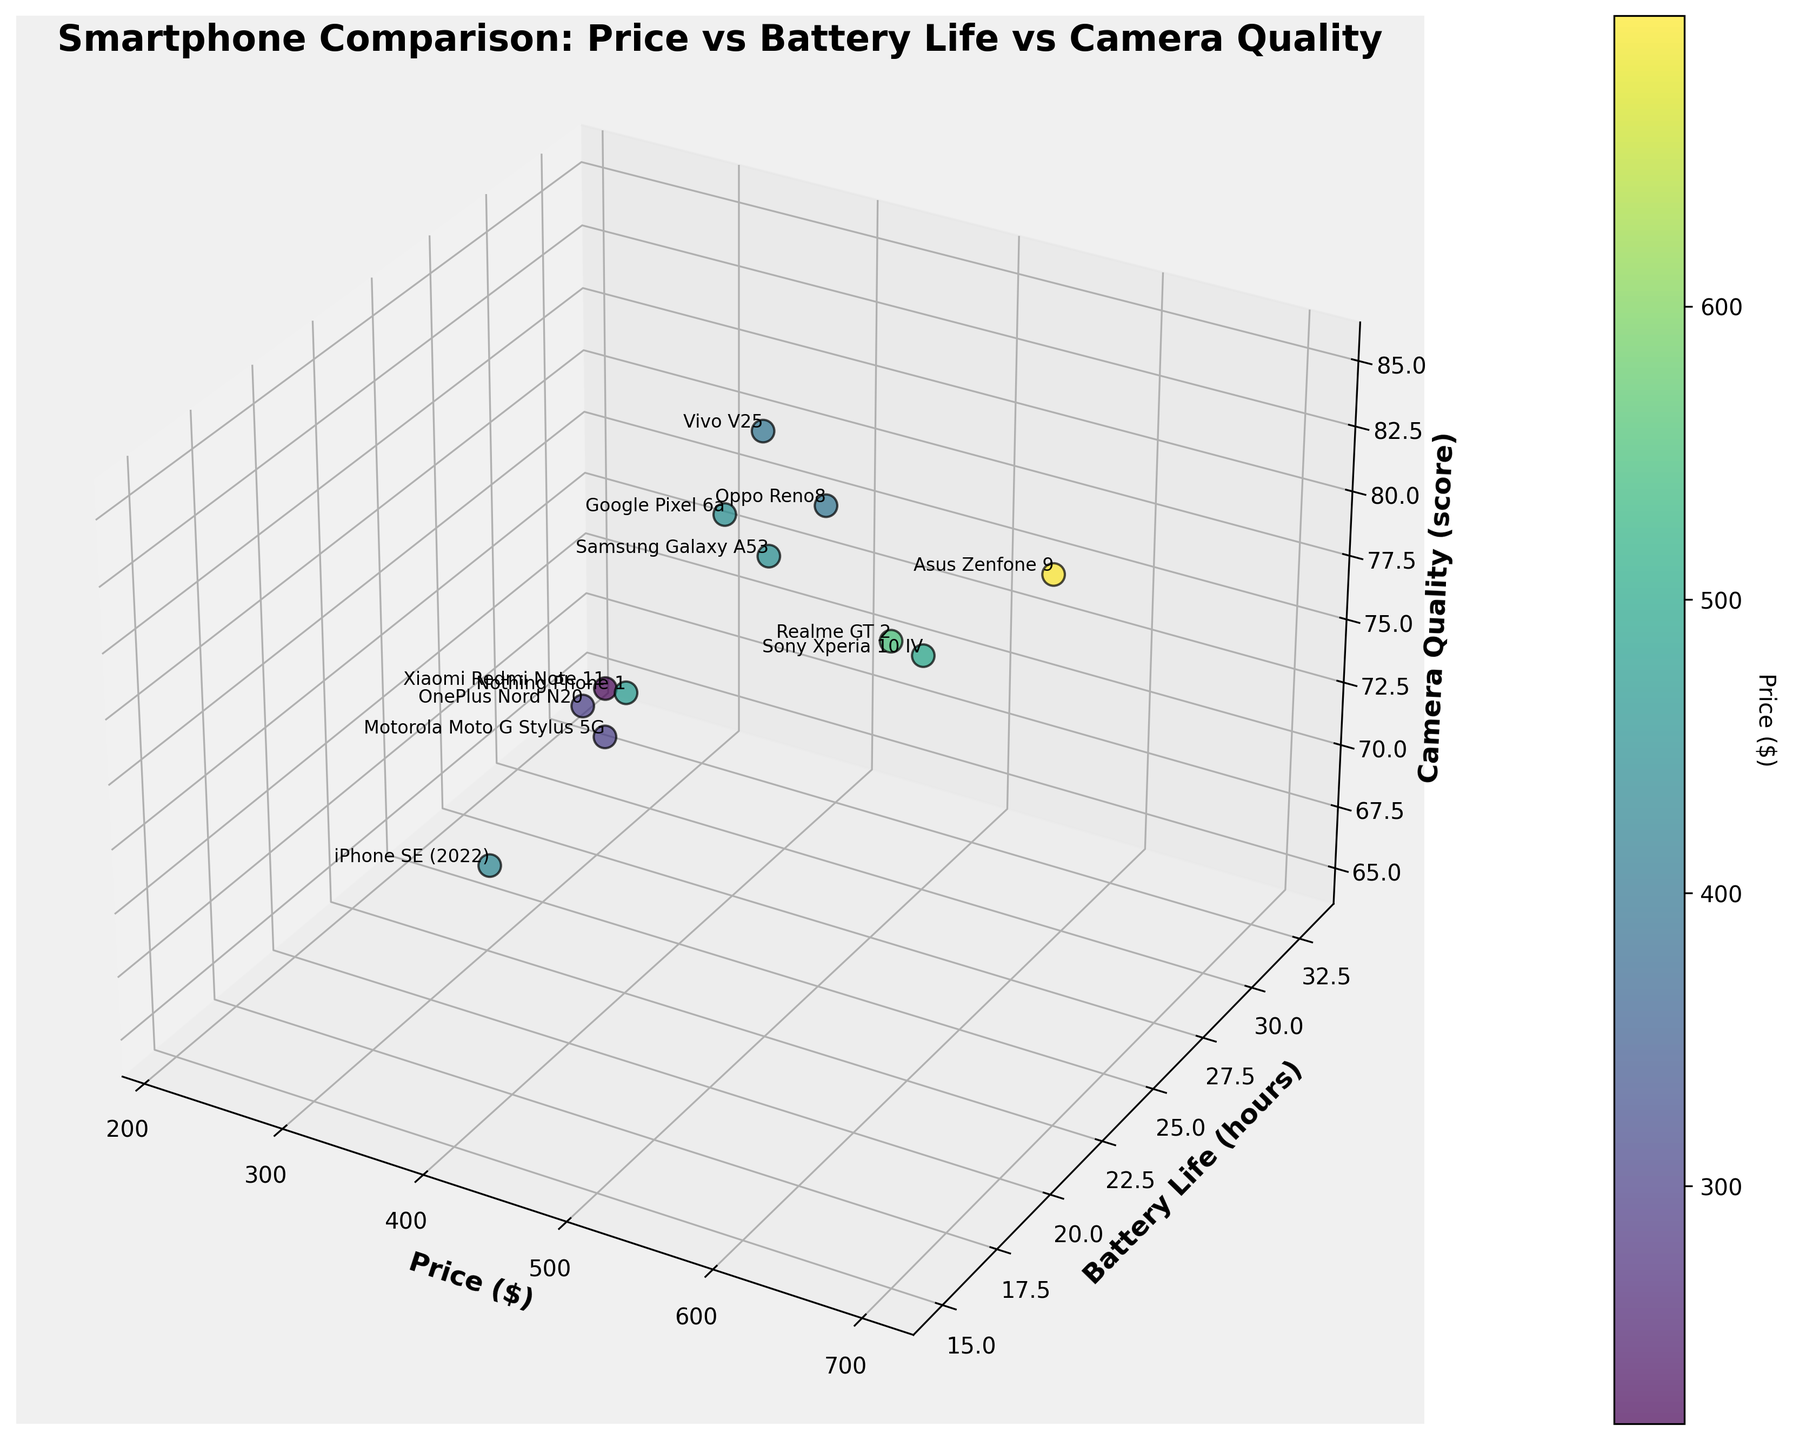Which smartphone model has the highest camera quality score? By referring to the camera quality axis, identify the highest point and read the associated model label.
Answer: Asus Zenfone 9 What is the title of the figure? Read the text at the top center of the figure.
Answer: Smartphone Comparison: Price vs Battery Life vs Camera Quality How many smartphone models have a battery life of at least 25 hours? Count the data points where the battery life value is 25 or more along the corresponding axis.
Answer: 8 What is the price range covered by the smartphone models in the plot? Find the minimum and maximum values on the price axis by locating the lowest and highest data points.
Answer: $219 to $699 Which smartphone model is the most expensive? Identify the data point with the highest value on the price axis and read the associated model label.
Answer: Asus Zenfone 9 Which model offers the best camera quality for a price below $500? Filter models costing below $500 and compare their camera quality scores to find the highest.
Answer: Sony Xperia 10 IV What is the difference in battery life between the OnePlus Nord N20 and the Oppo Reno8? Find the battery life values for both models on the axis and calculate the difference.
Answer: 5 hours Which model has the longest battery life and what is the value? Identify the highest value on the battery life axis and find the corresponding model label.
Answer: Xiaomi Redmi Note 11, 33 hours How are the models distributed regarding battery life and camera quality in the price range of $200 to $500? Focus on data points within the $200 to $500 price range and describe their positions on the battery life and camera quality axes.
Answer: Varied; Battery life ranges from 15 to 33 hours and camera quality ranges from 65 to 82 What is the median battery life of these smartphone models? Sort the battery life values and find the middle value if odd, average of two middle values if even.
Answer: 26 hours 